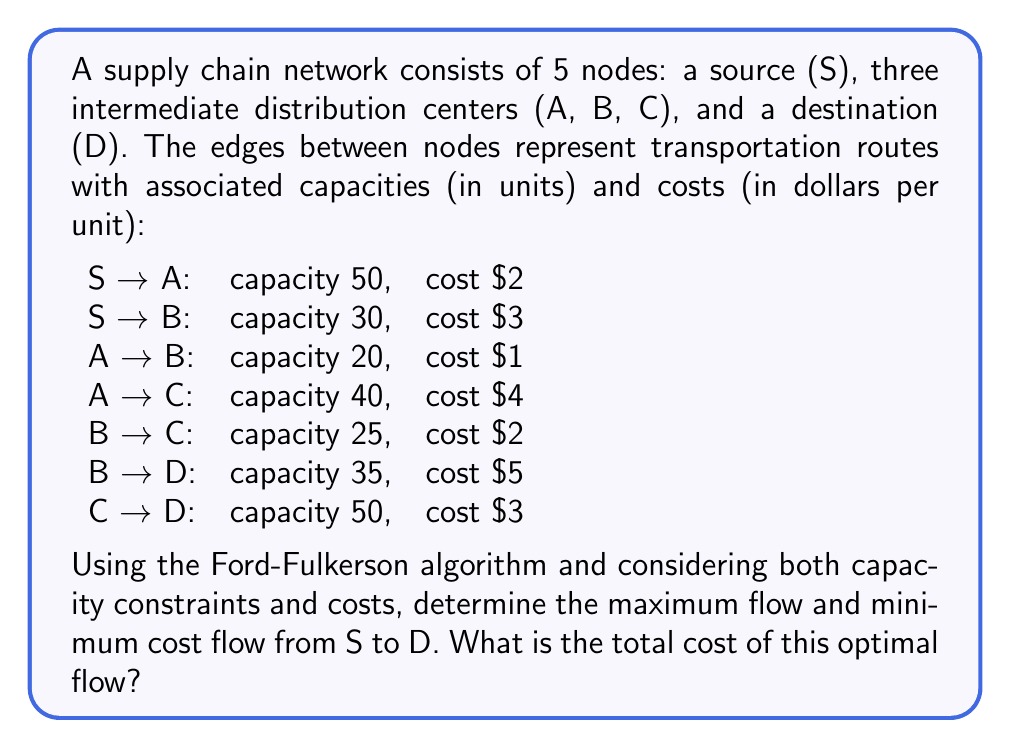Could you help me with this problem? To solve this problem, we'll use a combination of the Ford-Fulkerson algorithm for maximum flow and the successive shortest path algorithm for minimum cost flow. Let's break it down step-by-step:

1. First, we'll find the maximum flow using Ford-Fulkerson:

   a. Initial flow: 0
   b. Find augmenting paths and their bottlenecks:
      Path 1: S → A → C → D, bottleneck = min(50, 40, 50) = 40
      Path 2: S → B → D, bottleneck = min(30, 35) = 30
      Path 3: S → A → B → D, bottleneck = min(50-40, 20, 35-30) = 5
   c. Total maximum flow = 40 + 30 + 5 = 75

2. Now that we have the maximum flow, we'll use the successive shortest path algorithm to find the minimum cost flow:

   a. Start with zero flow and find the shortest path considering costs:
      S → A → B → D (cost: 2 + 1 + 5 = 8), push 30 units
   b. Update residual graph and find next shortest path:
      S → A → C → D (cost: 2 + 4 + 3 = 9), push 40 units
   c. Update residual graph and find next shortest path:
      S → B → D (cost: 3 + 5 = 8), push 5 units

3. Calculate the total cost:
   (30 * 8) + (40 * 9) + (5 * 8) = 240 + 360 + 40 = 640

The optimal flow distribution is:
- S → A: 70 units
- S → B: 5 units
- A → B: 30 units
- A → C: 40 units
- B → D: 35 units
- C → D: 40 units

This flow satisfies all capacity constraints and achieves the maximum flow of 75 units from S to D at the minimum total cost.
Answer: The total cost of the optimal flow is $640. 